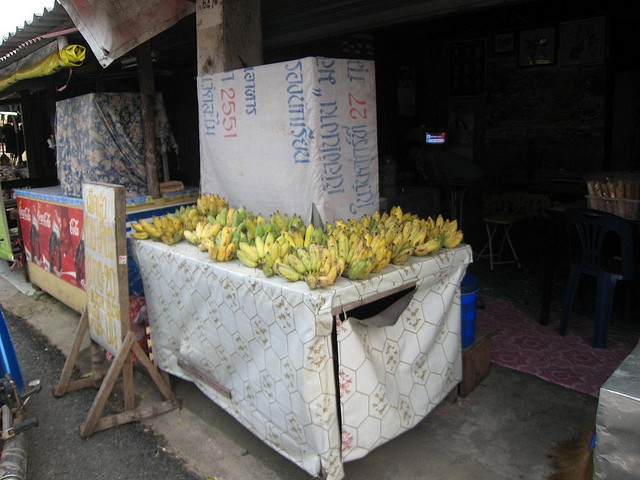Describe the objects in this image and their specific colors. I can see banana in white, olive, and khaki tones, chair in black, navy, and white tones, chair in black and white tones, banana in white, tan, and khaki tones, and banana in white, tan, and khaki tones in this image. 